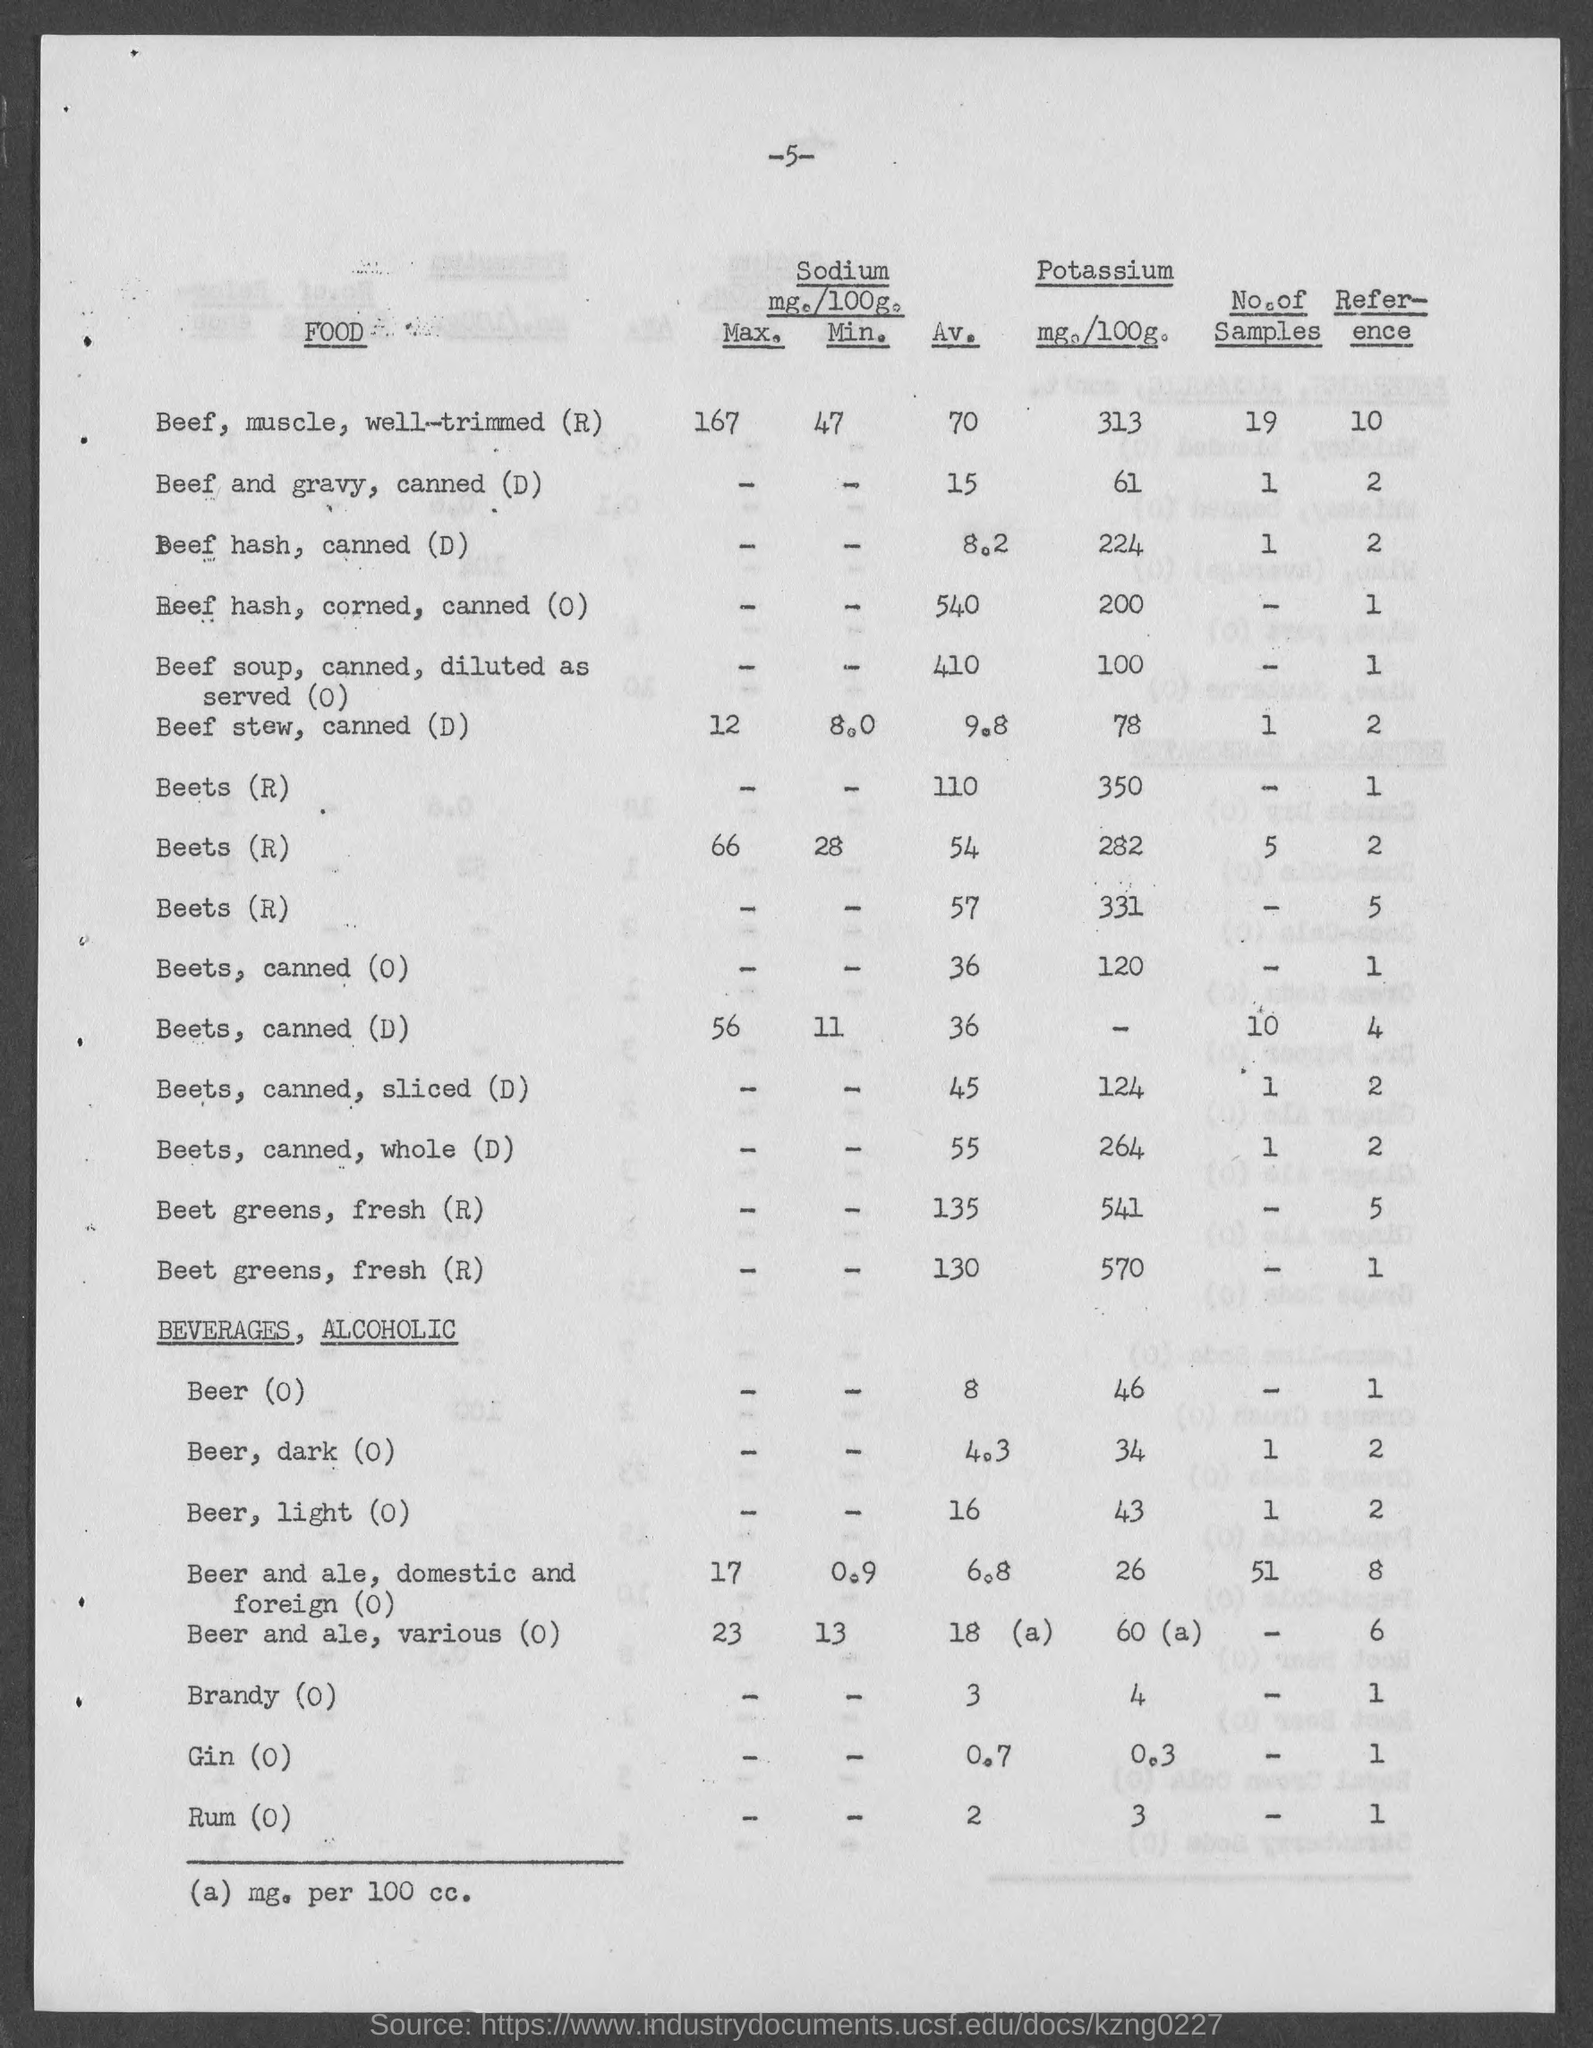What is the Av. sodium for Beets, canned (O)?
Offer a very short reply. 36. What is the potassium for Beets, canned (O)?
Provide a succinct answer. 120. What is the Av. sodium for Beets, canned (D)?
Give a very brief answer. 36. What is the Av. sodium for Beets, canned, sliced (D)?
Give a very brief answer. 45. What is the Potassium for Beets, canned, sliced (D)?
Your response must be concise. 124. What is the Av. sodium for Beets, canned, whole (D)?
Your response must be concise. 55. What is the Potassium for Beets, canned, whole (D)?
Keep it short and to the point. 264. What is the Av. sodium for Beer (0)?
Your answer should be compact. 8. 